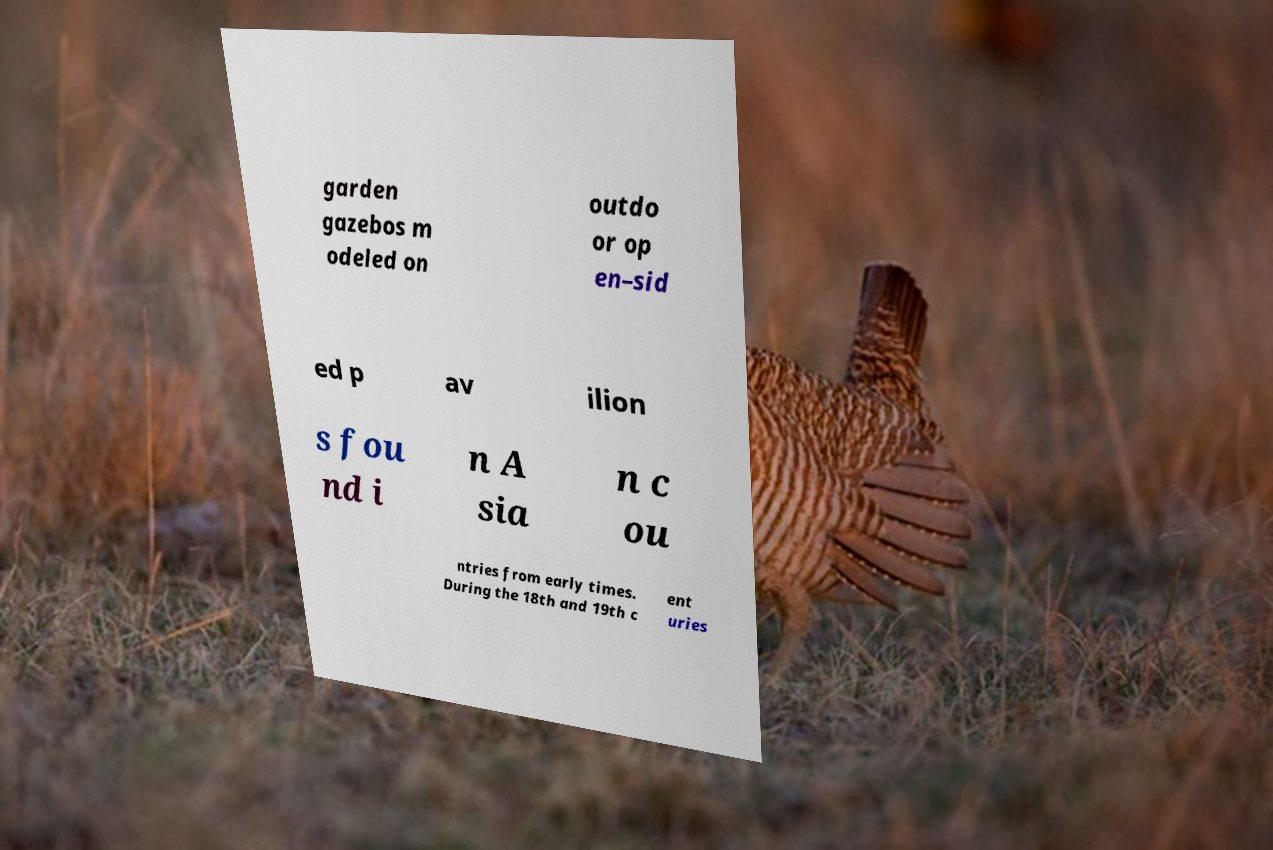Please read and relay the text visible in this image. What does it say? garden gazebos m odeled on outdo or op en–sid ed p av ilion s fou nd i n A sia n c ou ntries from early times. During the 18th and 19th c ent uries 